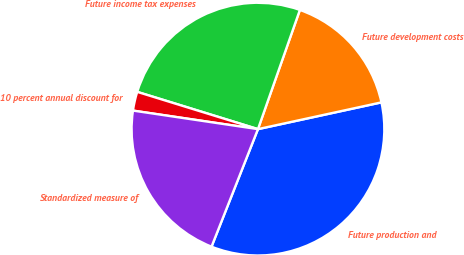Convert chart to OTSL. <chart><loc_0><loc_0><loc_500><loc_500><pie_chart><fcel>Future production and<fcel>Future development costs<fcel>Future income tax expenses<fcel>10 percent annual discount for<fcel>Standardized measure of<nl><fcel>34.39%<fcel>16.22%<fcel>25.62%<fcel>2.42%<fcel>21.36%<nl></chart> 